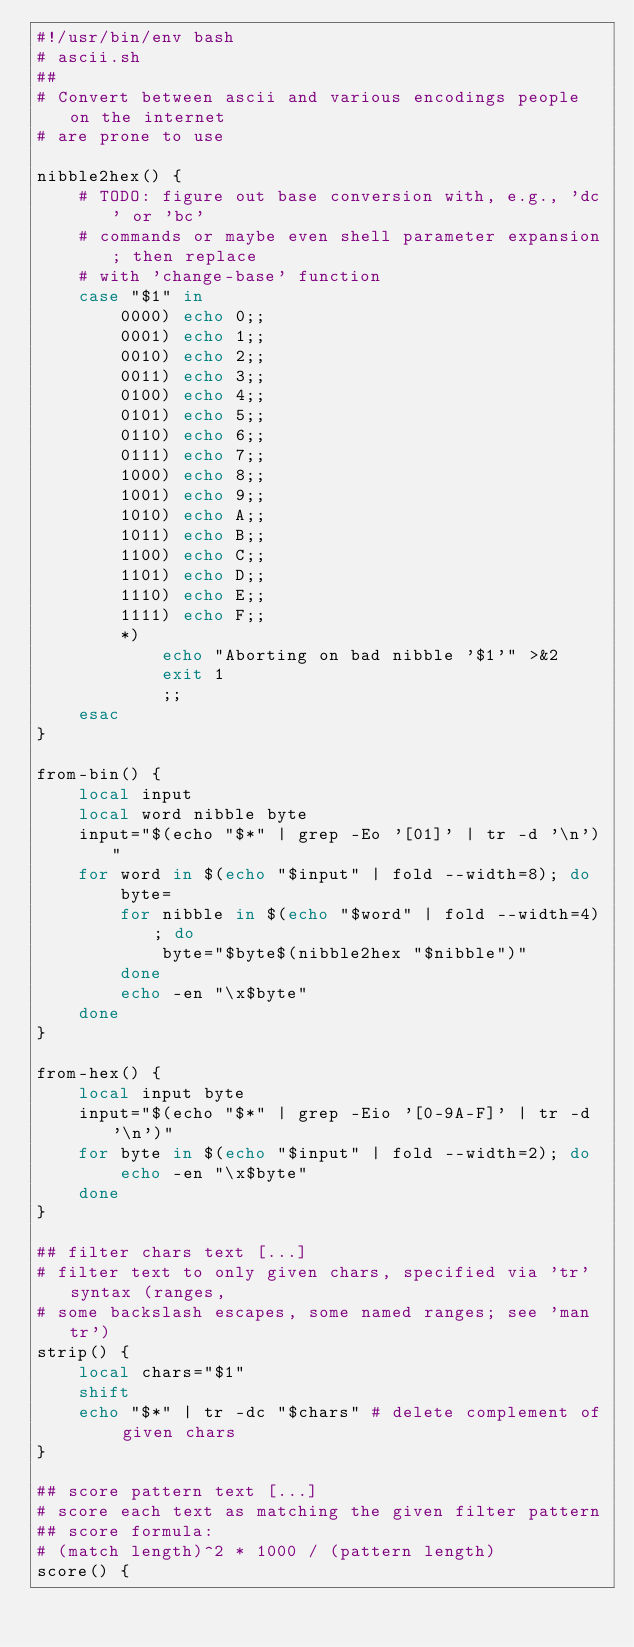Convert code to text. <code><loc_0><loc_0><loc_500><loc_500><_Bash_>#!/usr/bin/env bash
# ascii.sh
##
# Convert between ascii and various encodings people on the internet
# are prone to use

nibble2hex() {
    # TODO: figure out base conversion with, e.g., 'dc' or 'bc'
    # commands or maybe even shell parameter expansion; then replace
    # with 'change-base' function
    case "$1" in
        0000) echo 0;;
        0001) echo 1;;
        0010) echo 2;;
        0011) echo 3;;
        0100) echo 4;;
        0101) echo 5;;
        0110) echo 6;;
        0111) echo 7;;
        1000) echo 8;;
        1001) echo 9;;
        1010) echo A;;
        1011) echo B;;
        1100) echo C;;
        1101) echo D;;
        1110) echo E;;
        1111) echo F;;
        *)
            echo "Aborting on bad nibble '$1'" >&2
            exit 1
            ;;
    esac
}

from-bin() {
    local input
    local word nibble byte
    input="$(echo "$*" | grep -Eo '[01]' | tr -d '\n')"
    for word in $(echo "$input" | fold --width=8); do
        byte=
        for nibble in $(echo "$word" | fold --width=4); do
            byte="$byte$(nibble2hex "$nibble")"
        done
        echo -en "\x$byte"
    done
}

from-hex() {
    local input byte
    input="$(echo "$*" | grep -Eio '[0-9A-F]' | tr -d '\n')"
    for byte in $(echo "$input" | fold --width=2); do
        echo -en "\x$byte"
    done
}

## filter chars text [...]
# filter text to only given chars, specified via 'tr' syntax (ranges,
# some backslash escapes, some named ranges; see 'man tr')
strip() {
    local chars="$1"
    shift
    echo "$*" | tr -dc "$chars" # delete complement of given chars
}

## score pattern text [...]
# score each text as matching the given filter pattern
## score formula:
# (match length)^2 * 1000 / (pattern length)
score() {</code> 